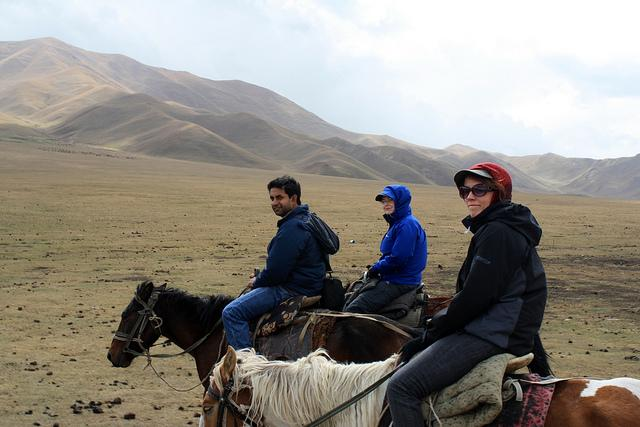What are the people turning to look at? Please explain your reasoning. camera. People are turning back to look at the camera. 